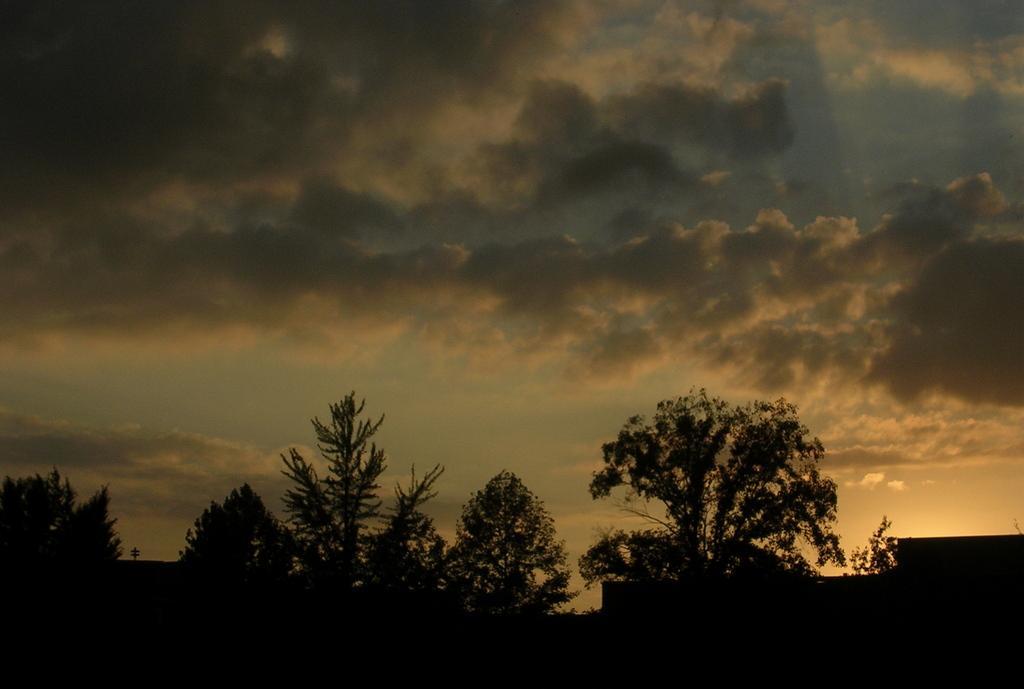Can you describe this image briefly? In this image I see the trees and the sky which is cloudy and I see it is dark over here. 